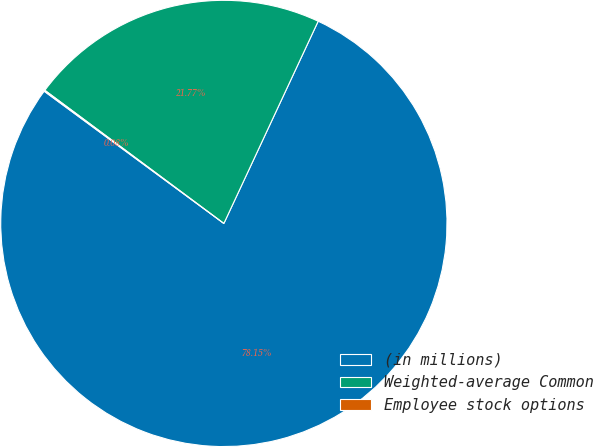Convert chart. <chart><loc_0><loc_0><loc_500><loc_500><pie_chart><fcel>(in millions)<fcel>Weighted-average Common<fcel>Employee stock options<nl><fcel>78.16%<fcel>21.77%<fcel>0.08%<nl></chart> 